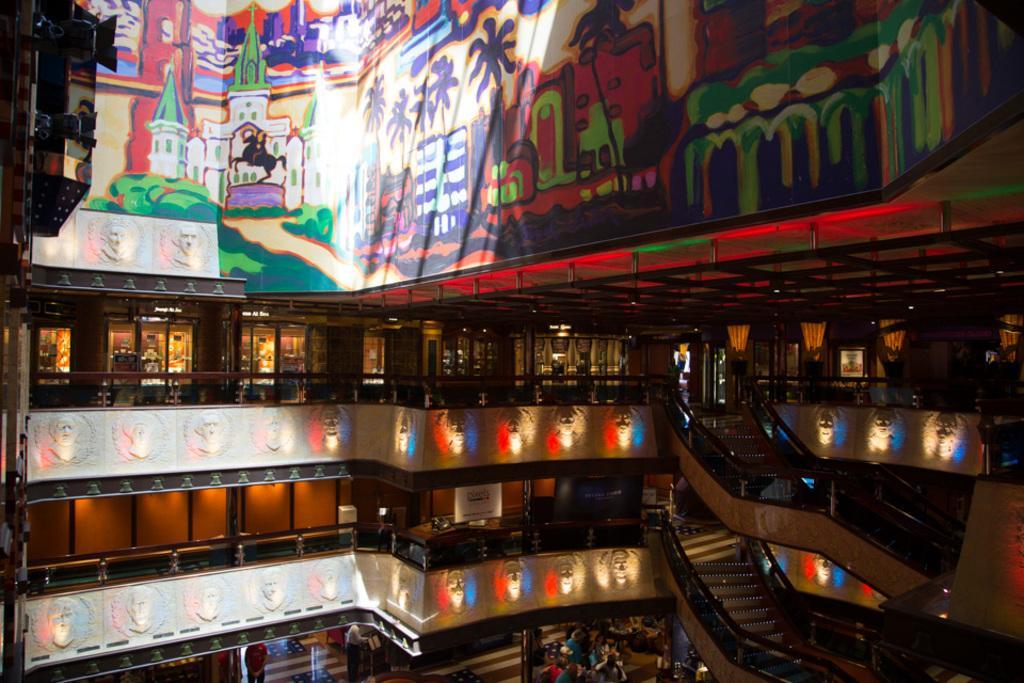Could you give a brief overview of what you see in this image? This is a building and a horse, these are stairs and plants. 